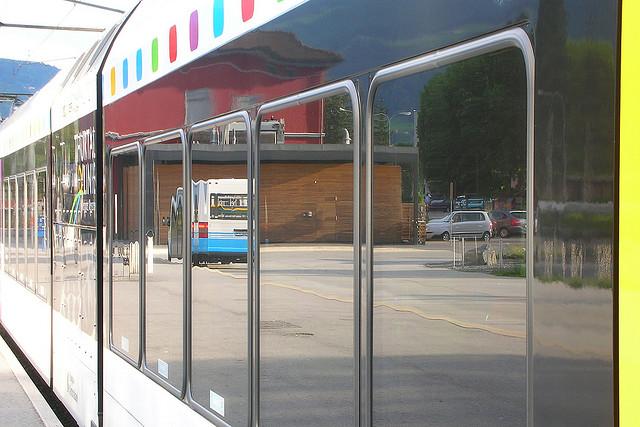Is there a reflection?
Answer briefly. Yes. Is the train clean?
Be succinct. Yes. Is this a passenger train?
Give a very brief answer. Yes. 